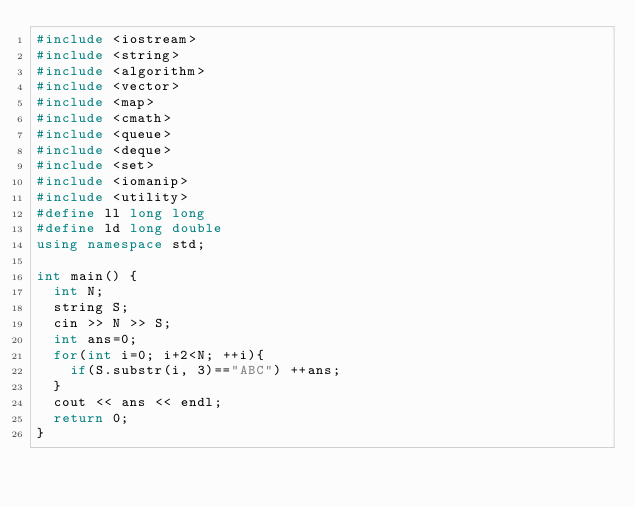<code> <loc_0><loc_0><loc_500><loc_500><_C++_>#include <iostream>
#include <string>
#include <algorithm>
#include <vector>
#include <map>
#include <cmath>
#include <queue>
#include <deque>
#include <set>
#include <iomanip>
#include <utility>
#define ll long long
#define ld long double
using namespace std;

int main() {
	int N;
	string S;
	cin >> N >> S;
	int ans=0;
	for(int i=0; i+2<N; ++i){
		if(S.substr(i, 3)=="ABC") ++ans;
	}
	cout << ans << endl;
	return 0;
}</code> 